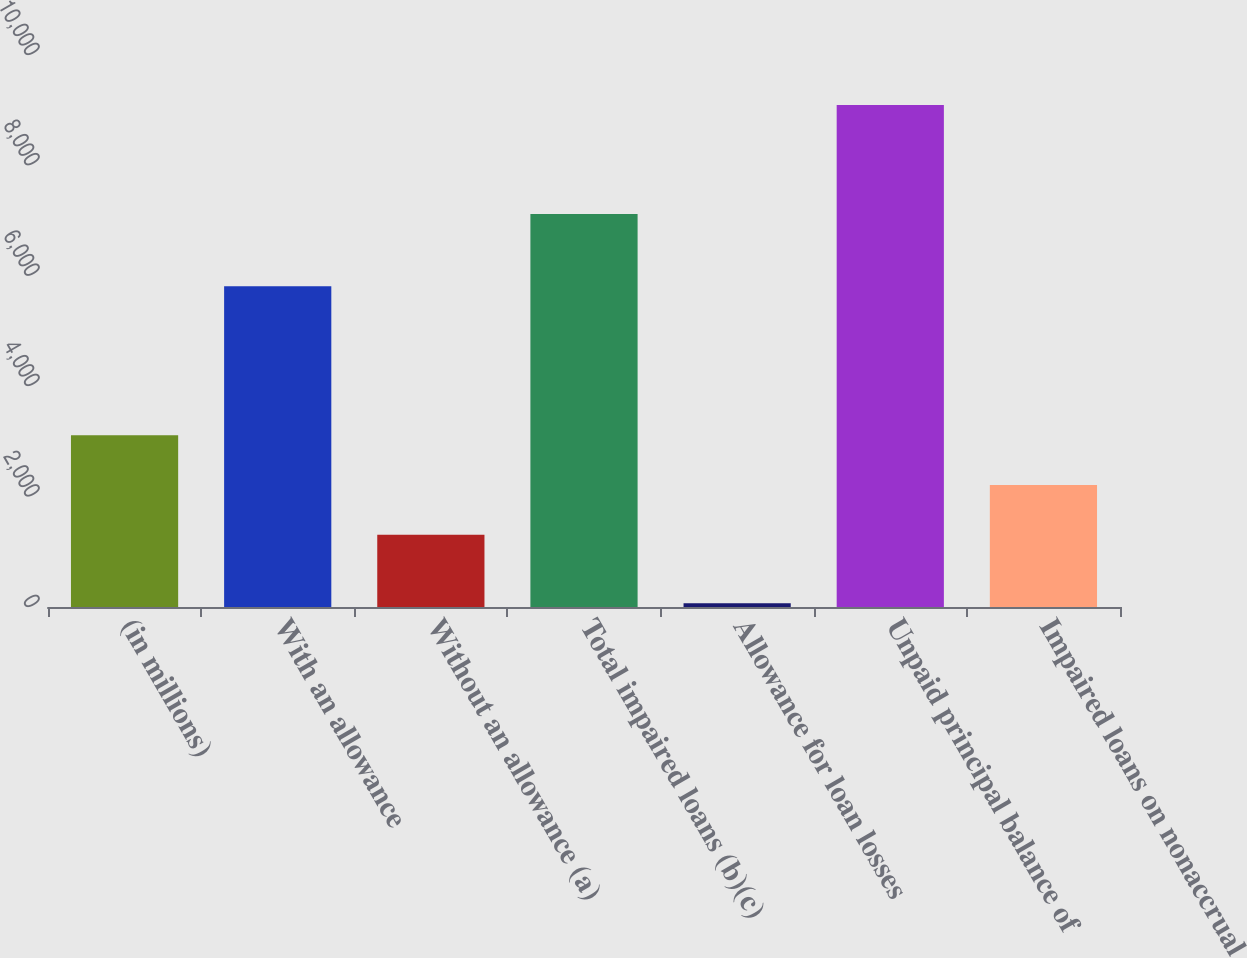Convert chart. <chart><loc_0><loc_0><loc_500><loc_500><bar_chart><fcel>(in millions)<fcel>With an allowance<fcel>Without an allowance (a)<fcel>Total impaired loans (b)(c)<fcel>Allowance for loan losses<fcel>Unpaid principal balance of<fcel>Impaired loans on nonaccrual<nl><fcel>3113<fcel>5810<fcel>1308<fcel>7118<fcel>70<fcel>9095<fcel>2210.5<nl></chart> 